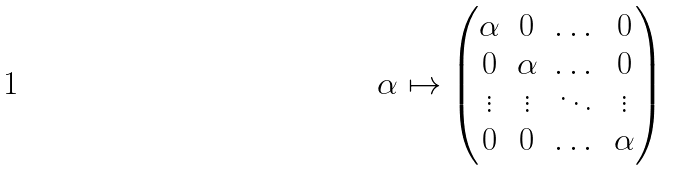Convert formula to latex. <formula><loc_0><loc_0><loc_500><loc_500>\alpha \mapsto \begin{pmatrix} \alpha & 0 & \dots & 0 \\ 0 & \alpha & \dots & 0 \\ \vdots & \vdots & \ddots & \vdots \\ 0 & 0 & \dots & \alpha \\ \end{pmatrix}</formula> 